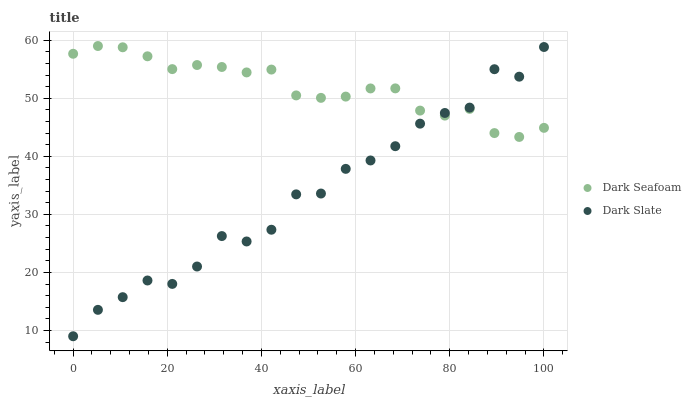Does Dark Slate have the minimum area under the curve?
Answer yes or no. Yes. Does Dark Seafoam have the maximum area under the curve?
Answer yes or no. Yes. Does Dark Seafoam have the minimum area under the curve?
Answer yes or no. No. Is Dark Seafoam the smoothest?
Answer yes or no. Yes. Is Dark Slate the roughest?
Answer yes or no. Yes. Is Dark Seafoam the roughest?
Answer yes or no. No. Does Dark Slate have the lowest value?
Answer yes or no. Yes. Does Dark Seafoam have the lowest value?
Answer yes or no. No. Does Dark Seafoam have the highest value?
Answer yes or no. Yes. Does Dark Seafoam intersect Dark Slate?
Answer yes or no. Yes. Is Dark Seafoam less than Dark Slate?
Answer yes or no. No. Is Dark Seafoam greater than Dark Slate?
Answer yes or no. No. 